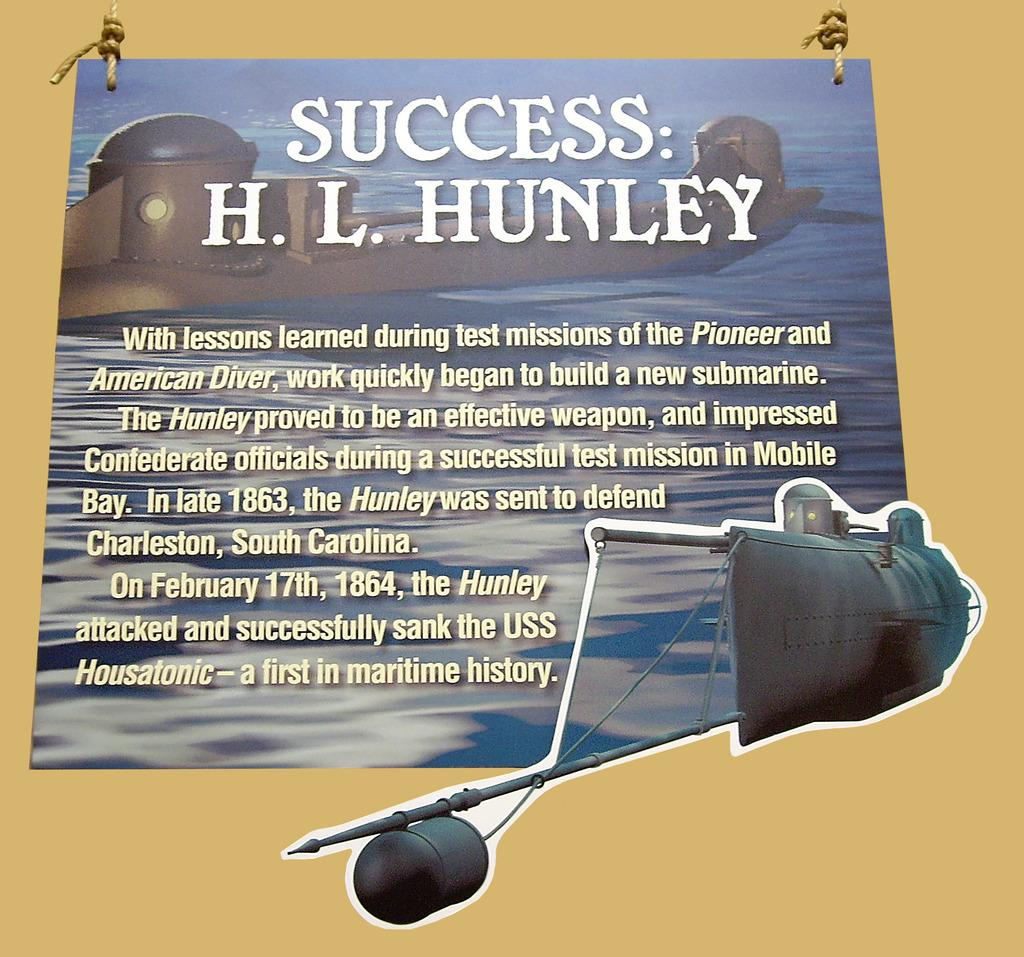<image>
Render a clear and concise summary of the photo. A sign that has a submarine on it and says Success: H.L. Hunley. 